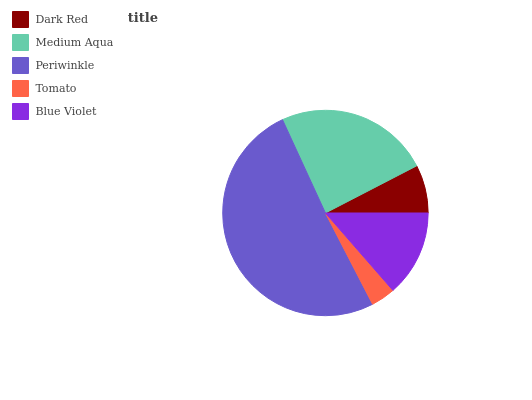Is Tomato the minimum?
Answer yes or no. Yes. Is Periwinkle the maximum?
Answer yes or no. Yes. Is Medium Aqua the minimum?
Answer yes or no. No. Is Medium Aqua the maximum?
Answer yes or no. No. Is Medium Aqua greater than Dark Red?
Answer yes or no. Yes. Is Dark Red less than Medium Aqua?
Answer yes or no. Yes. Is Dark Red greater than Medium Aqua?
Answer yes or no. No. Is Medium Aqua less than Dark Red?
Answer yes or no. No. Is Blue Violet the high median?
Answer yes or no. Yes. Is Blue Violet the low median?
Answer yes or no. Yes. Is Periwinkle the high median?
Answer yes or no. No. Is Periwinkle the low median?
Answer yes or no. No. 